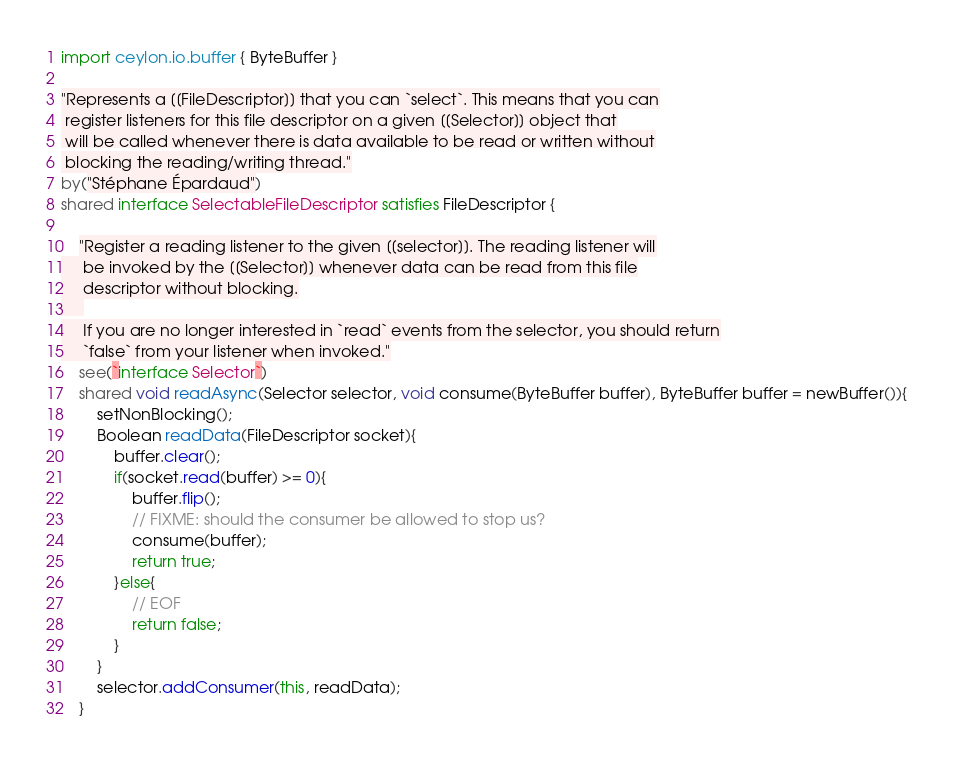Convert code to text. <code><loc_0><loc_0><loc_500><loc_500><_Ceylon_>import ceylon.io.buffer { ByteBuffer }

"Represents a [[FileDescriptor]] that you can `select`. This means that you can
 register listeners for this file descriptor on a given [[Selector]] object that
 will be called whenever there is data available to be read or written without
 blocking the reading/writing thread."
by("Stéphane Épardaud")
shared interface SelectableFileDescriptor satisfies FileDescriptor {

    "Register a reading listener to the given [[selector]]. The reading listener will
     be invoked by the [[Selector]] whenever data can be read from this file
     descriptor without blocking.
     
     If you are no longer interested in `read` events from the selector, you should return
     `false` from your listener when invoked."
    see(`interface Selector`)
    shared void readAsync(Selector selector, void consume(ByteBuffer buffer), ByteBuffer buffer = newBuffer()){
        setNonBlocking();
        Boolean readData(FileDescriptor socket){
            buffer.clear();
            if(socket.read(buffer) >= 0){
                buffer.flip();
                // FIXME: should the consumer be allowed to stop us?
                consume(buffer);
                return true;
            }else{
                // EOF
                return false;
            }
        }
        selector.addConsumer(this, readData);
    }
</code> 